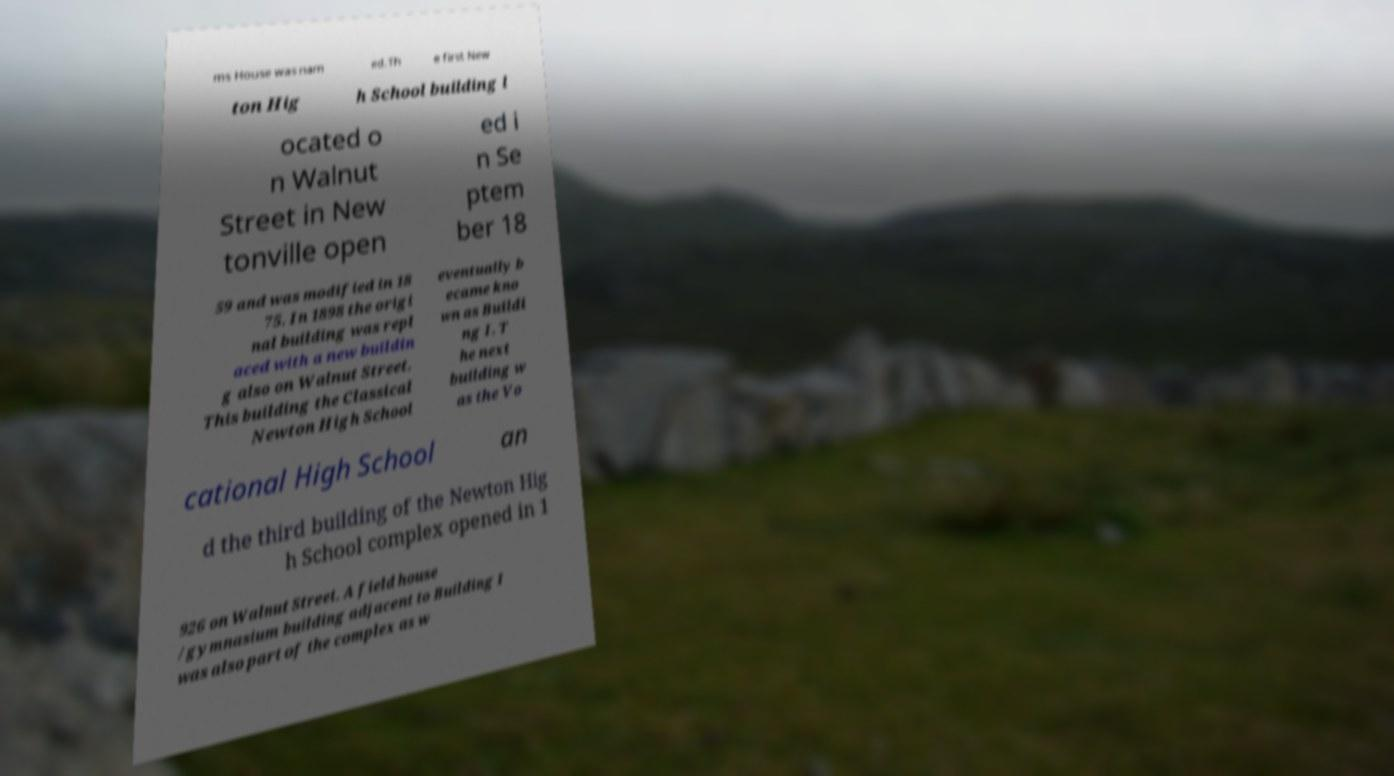What messages or text are displayed in this image? I need them in a readable, typed format. ms House was nam ed.Th e first New ton Hig h School building l ocated o n Walnut Street in New tonville open ed i n Se ptem ber 18 59 and was modified in 18 75. In 1898 the origi nal building was repl aced with a new buildin g also on Walnut Street. This building the Classical Newton High School eventually b ecame kno wn as Buildi ng I. T he next building w as the Vo cational High School an d the third building of the Newton Hig h School complex opened in 1 926 on Walnut Street. A field house /gymnasium building adjacent to Building I was also part of the complex as w 